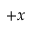<formula> <loc_0><loc_0><loc_500><loc_500>+ x</formula> 